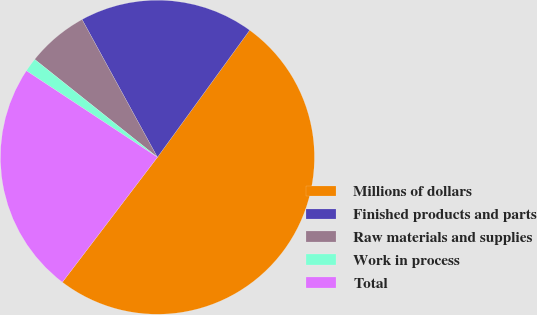Convert chart to OTSL. <chart><loc_0><loc_0><loc_500><loc_500><pie_chart><fcel>Millions of dollars<fcel>Finished products and parts<fcel>Raw materials and supplies<fcel>Work in process<fcel>Total<nl><fcel>50.35%<fcel>17.96%<fcel>6.32%<fcel>1.43%<fcel>23.93%<nl></chart> 